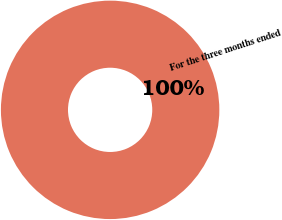Convert chart. <chart><loc_0><loc_0><loc_500><loc_500><pie_chart><fcel>For the three months ended<nl><fcel>100.0%<nl></chart> 